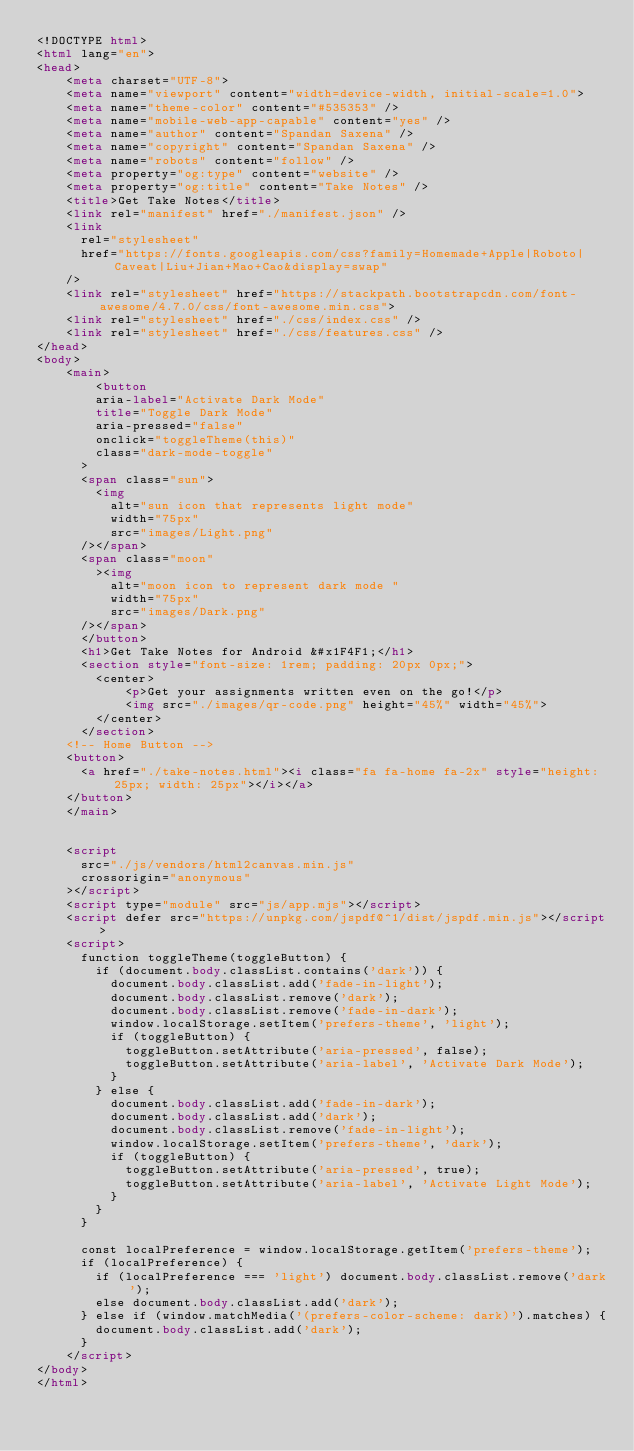<code> <loc_0><loc_0><loc_500><loc_500><_HTML_><!DOCTYPE html>
<html lang="en">
<head>
    <meta charset="UTF-8">
    <meta name="viewport" content="width=device-width, initial-scale=1.0">
    <meta name="theme-color" content="#535353" />
    <meta name="mobile-web-app-capable" content="yes" />
    <meta name="author" content="Spandan Saxena" />
    <meta name="copyright" content="Spandan Saxena" />
    <meta name="robots" content="follow" />
    <meta property="og:type" content="website" />
    <meta property="og:title" content="Take Notes" />
    <title>Get Take Notes</title>
    <link rel="manifest" href="./manifest.json" />
    <link
      rel="stylesheet"
      href="https://fonts.googleapis.com/css?family=Homemade+Apple|Roboto|Caveat|Liu+Jian+Mao+Cao&display=swap"
    />
    <link rel="stylesheet" href="https://stackpath.bootstrapcdn.com/font-awesome/4.7.0/css/font-awesome.min.css">
    <link rel="stylesheet" href="./css/index.css" />
    <link rel="stylesheet" href="./css/features.css" />
</head>
<body>
    <main>
        <button
        aria-label="Activate Dark Mode"
        title="Toggle Dark Mode"
        aria-pressed="false"
        onclick="toggleTheme(this)"
        class="dark-mode-toggle"
      >
      <span class="sun">
        <img
          alt="sun icon that represents light mode"
          width="75px"
          src="images/Light.png"
      /></span>
      <span class="moon"
        ><img
          alt="moon icon to represent dark mode "
          width="75px"
          src="images/Dark.png"
      /></span>
      </button>
      <h1>Get Take Notes for Android &#x1F4F1;</h1>
      <section style="font-size: 1rem; padding: 20px 0px;">
        <center>
            <p>Get your assignments written even on the go!</p>
            <img src="./images/qr-code.png" height="45%" width="45%">
        </center>
      </section>      
    <!-- Home Button -->
    <button>
      <a href="./take-notes.html"><i class="fa fa-home fa-2x" style="height: 25px; width: 25px"></i></a>
    </button>
    </main>

        
    <script
      src="./js/vendors/html2canvas.min.js"
      crossorigin="anonymous"
    ></script>
    <script type="module" src="js/app.mjs"></script>
    <script defer src="https://unpkg.com/jspdf@^1/dist/jspdf.min.js"></script>
    <script>
      function toggleTheme(toggleButton) {
        if (document.body.classList.contains('dark')) {
          document.body.classList.add('fade-in-light');
          document.body.classList.remove('dark');
          document.body.classList.remove('fade-in-dark');
          window.localStorage.setItem('prefers-theme', 'light');
          if (toggleButton) {
            toggleButton.setAttribute('aria-pressed', false);
            toggleButton.setAttribute('aria-label', 'Activate Dark Mode');
          }
        } else {
          document.body.classList.add('fade-in-dark');
          document.body.classList.add('dark');
          document.body.classList.remove('fade-in-light');
          window.localStorage.setItem('prefers-theme', 'dark');
          if (toggleButton) {
            toggleButton.setAttribute('aria-pressed', true);
            toggleButton.setAttribute('aria-label', 'Activate Light Mode');
          }
        }
      }

      const localPreference = window.localStorage.getItem('prefers-theme');
      if (localPreference) {
        if (localPreference === 'light') document.body.classList.remove('dark');
        else document.body.classList.add('dark');
      } else if (window.matchMedia('(prefers-color-scheme: dark)').matches) {
        document.body.classList.add('dark');
      }
    </script>
</body>
</html></code> 